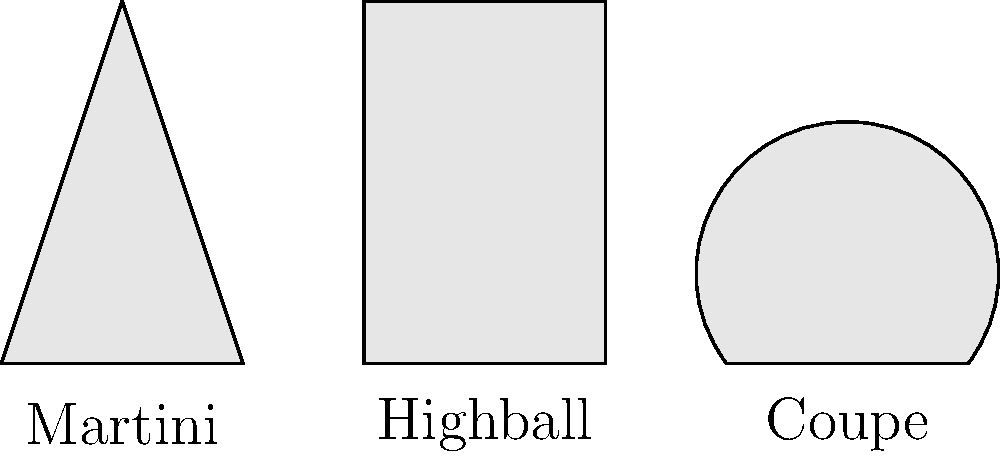As a hotel bartender, you're tasked with calculating the volumes of different cocktail glasses. Given that the Martini glass is a cone with a height of 15 cm and a radius of 7.5 cm, the Highball glass is a cylinder with a height of 15 cm and a radius of 3.75 cm, and the Coupe glass is a hemisphere with a radius of 5 cm, which glass has the largest volume? Express your final answer in cubic centimeters (cm³), rounded to the nearest whole number. Let's calculate the volume of each glass:

1. Martini glass (cone):
   Volume = $\frac{1}{3}\pi r^2 h$
   $V_{martini} = \frac{1}{3} \pi (7.5\text{ cm})^2 (15\text{ cm}) = 293.21\text{ cm}^3$

2. Highball glass (cylinder):
   Volume = $\pi r^2 h$
   $V_{highball} = \pi (3.75\text{ cm})^2 (15\text{ cm}) = 662.73\text{ cm}^3$

3. Coupe glass (hemisphere):
   Volume = $\frac{2}{3}\pi r^3$
   $V_{coupe} = \frac{2}{3} \pi (5\text{ cm})^3 = 261.80\text{ cm}^3$

Comparing the volumes:
Highball (662.73 cm³) > Martini (293.21 cm³) > Coupe (261.80 cm³)

The Highball glass has the largest volume at approximately 663 cm³ when rounded to the nearest whole number.
Answer: 663 cm³ 